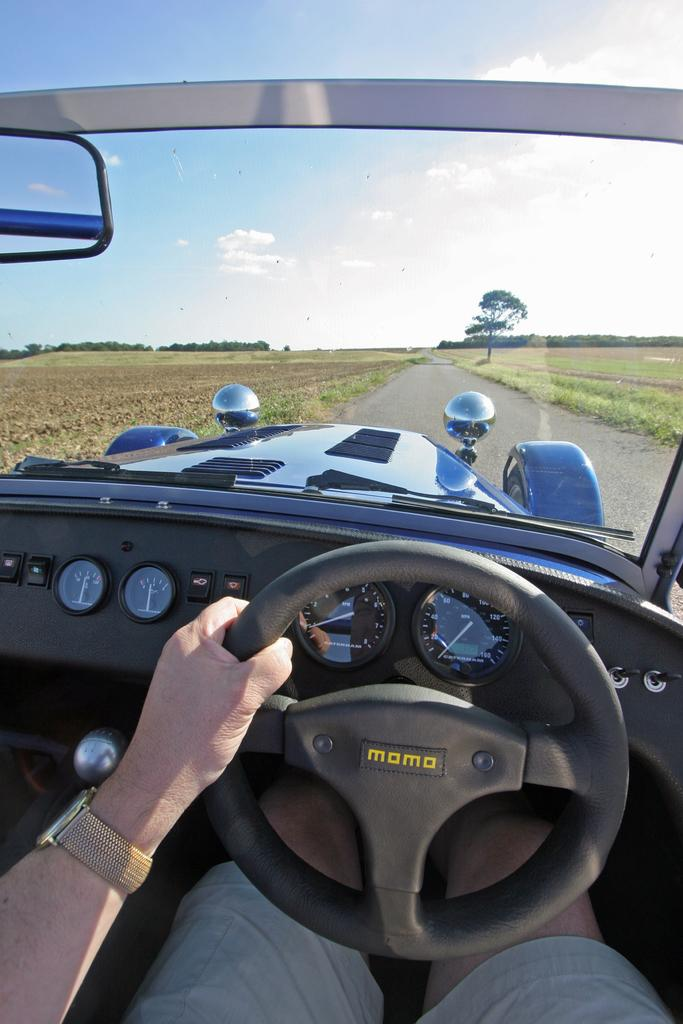What is the person in the image doing? There is a person sitting in a vehicle, and they are holding the steering wheel with one hand. What can be seen on the ground near the vehicle? The ground is covered with greenery on either side of the vehicle. What is visible in the background of the image? There are trees in the background of the image. What type of stem can be seen in the person's hand in the image? There is no stem present in the person's hand in the image; they are holding the steering wheel. What type of wool is being used to teach the person how to drive in the image? There is no wool or teaching depicted in the image; the person is simply holding the steering wheel. 